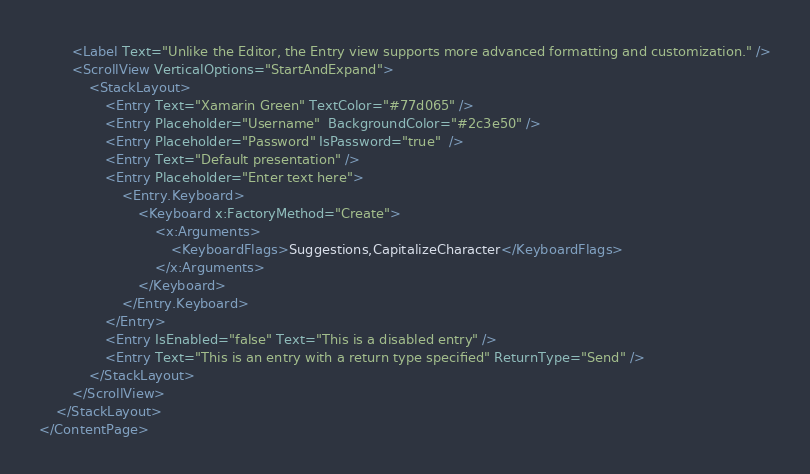Convert code to text. <code><loc_0><loc_0><loc_500><loc_500><_XML_>		<Label Text="Unlike the Editor, the Entry view supports more advanced formatting and customization." />
		<ScrollView VerticalOptions="StartAndExpand">
			<StackLayout>
				<Entry Text="Xamarin Green" TextColor="#77d065" />
				<Entry Placeholder="Username"  BackgroundColor="#2c3e50" />
				<Entry Placeholder="Password" IsPassword="true"  />
				<Entry Text="Default presentation" />
                <Entry Placeholder="Enter text here">
                    <Entry.Keyboard>
                        <Keyboard x:FactoryMethod="Create">
                            <x:Arguments>
                                <KeyboardFlags>Suggestions,CapitalizeCharacter</KeyboardFlags>
                            </x:Arguments>
                        </Keyboard>
                    </Entry.Keyboard>
                </Entry>
				<Entry IsEnabled="false" Text="This is a disabled entry" />
				<Entry Text="This is an entry with a return type specified" ReturnType="Send" />
			</StackLayout>
		</ScrollView>
	</StackLayout>
</ContentPage>
</code> 